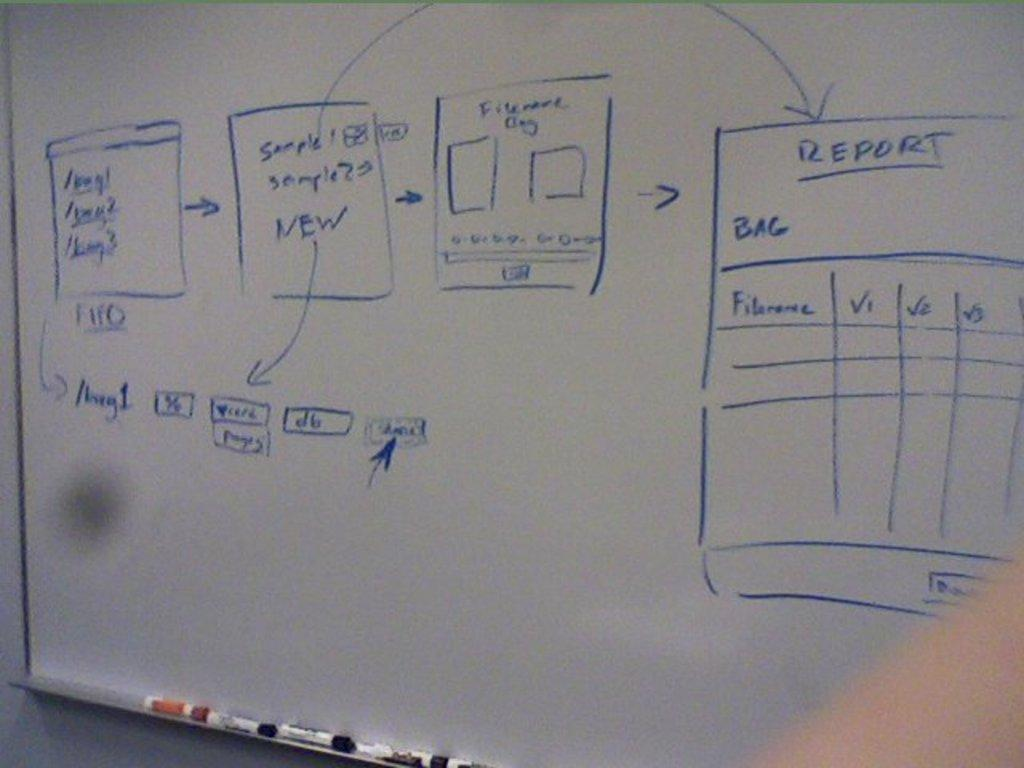Provide a one-sentence caption for the provided image. Blue marker on a white board show with a report box that has file name, and V1, V2, and V3. 